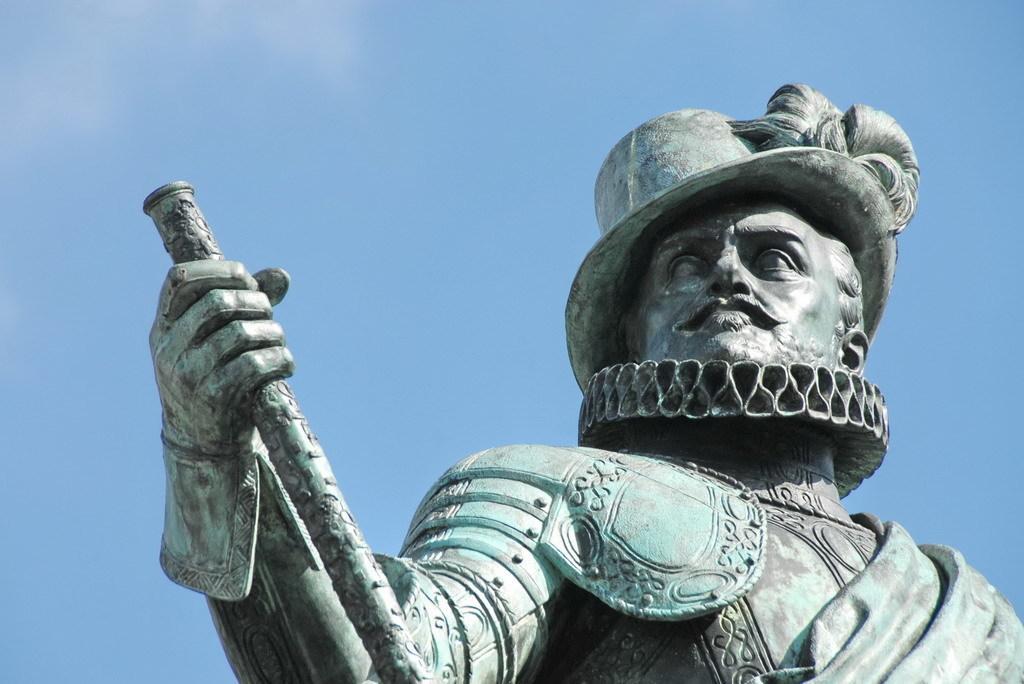Please provide a concise description of this image. On the right side, there is a statue of a person wearing a cap and holding a stick with one hand. In the background, there are clouds in the blue sky. 